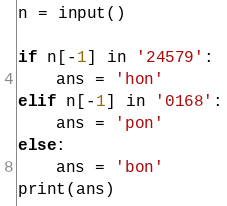Convert code to text. <code><loc_0><loc_0><loc_500><loc_500><_Python_>n = input()

if n[-1] in '24579':
    ans = 'hon'
elif n[-1] in '0168':
    ans = 'pon'
else:
    ans = 'bon'
print(ans)

</code> 